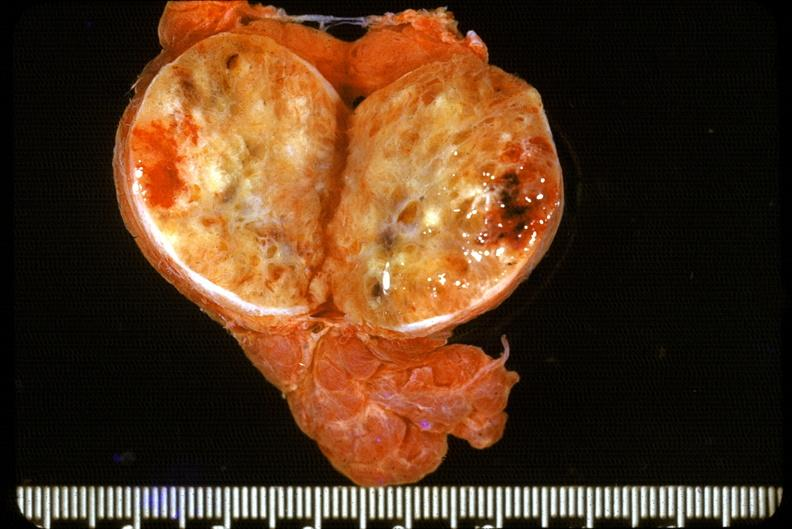what is present?
Answer the question using a single word or phrase. Endocrine 